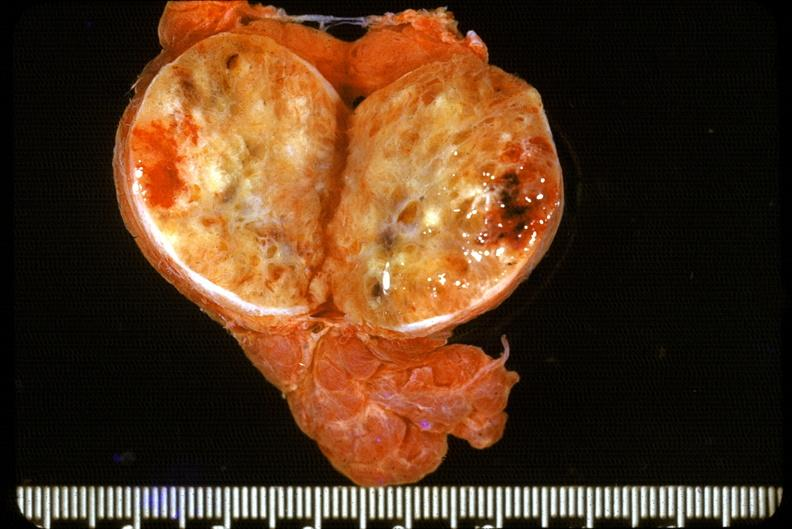what is present?
Answer the question using a single word or phrase. Endocrine 